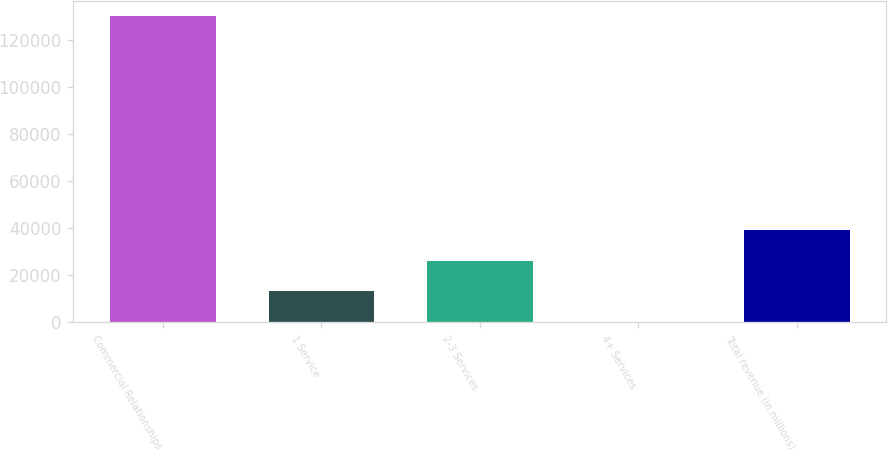Convert chart. <chart><loc_0><loc_0><loc_500><loc_500><bar_chart><fcel>Commercial Relationships<fcel>1 Service<fcel>2-3 Services<fcel>4+ Services<fcel>Total revenue (in millions)<nl><fcel>130240<fcel>13046.9<fcel>26068.3<fcel>25.4<fcel>39089.8<nl></chart> 